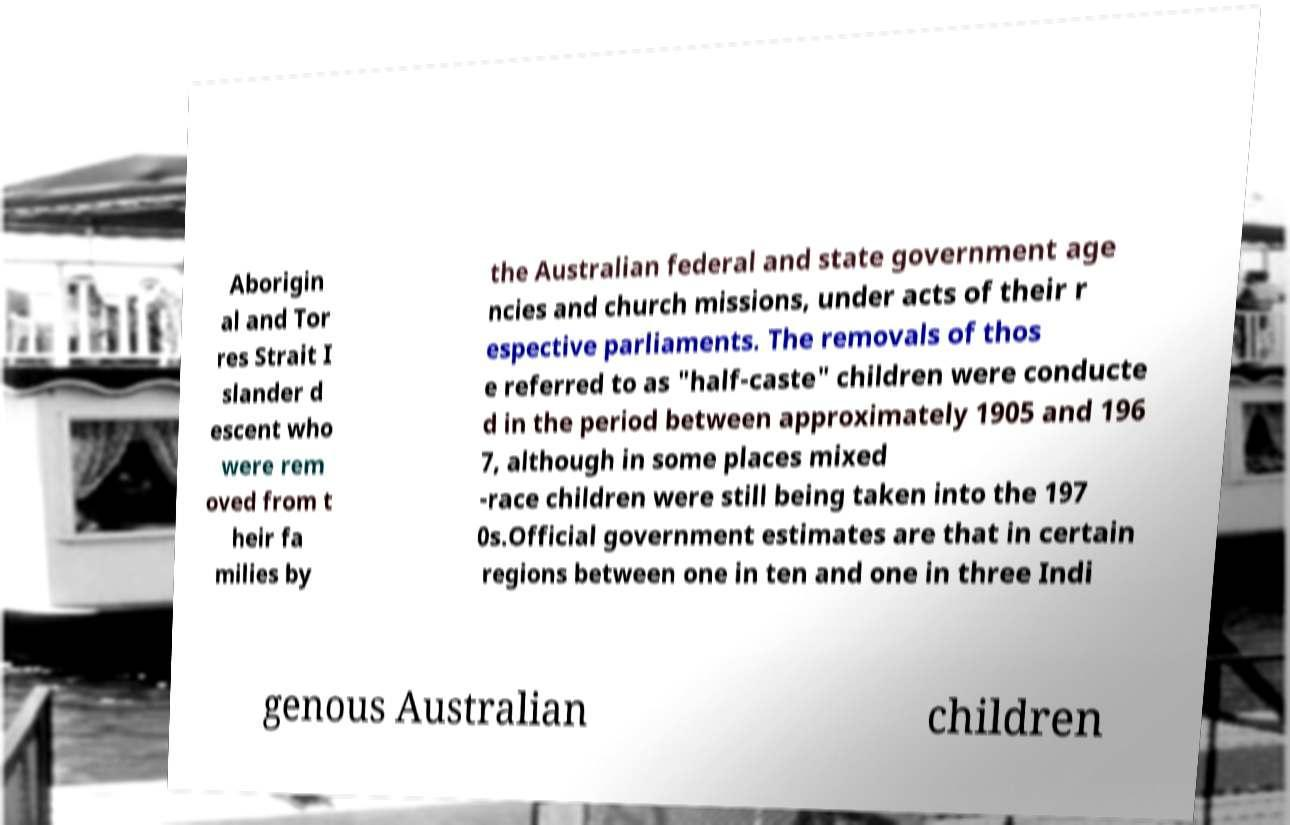Could you extract and type out the text from this image? Aborigin al and Tor res Strait I slander d escent who were rem oved from t heir fa milies by the Australian federal and state government age ncies and church missions, under acts of their r espective parliaments. The removals of thos e referred to as "half-caste" children were conducte d in the period between approximately 1905 and 196 7, although in some places mixed -race children were still being taken into the 197 0s.Official government estimates are that in certain regions between one in ten and one in three Indi genous Australian children 